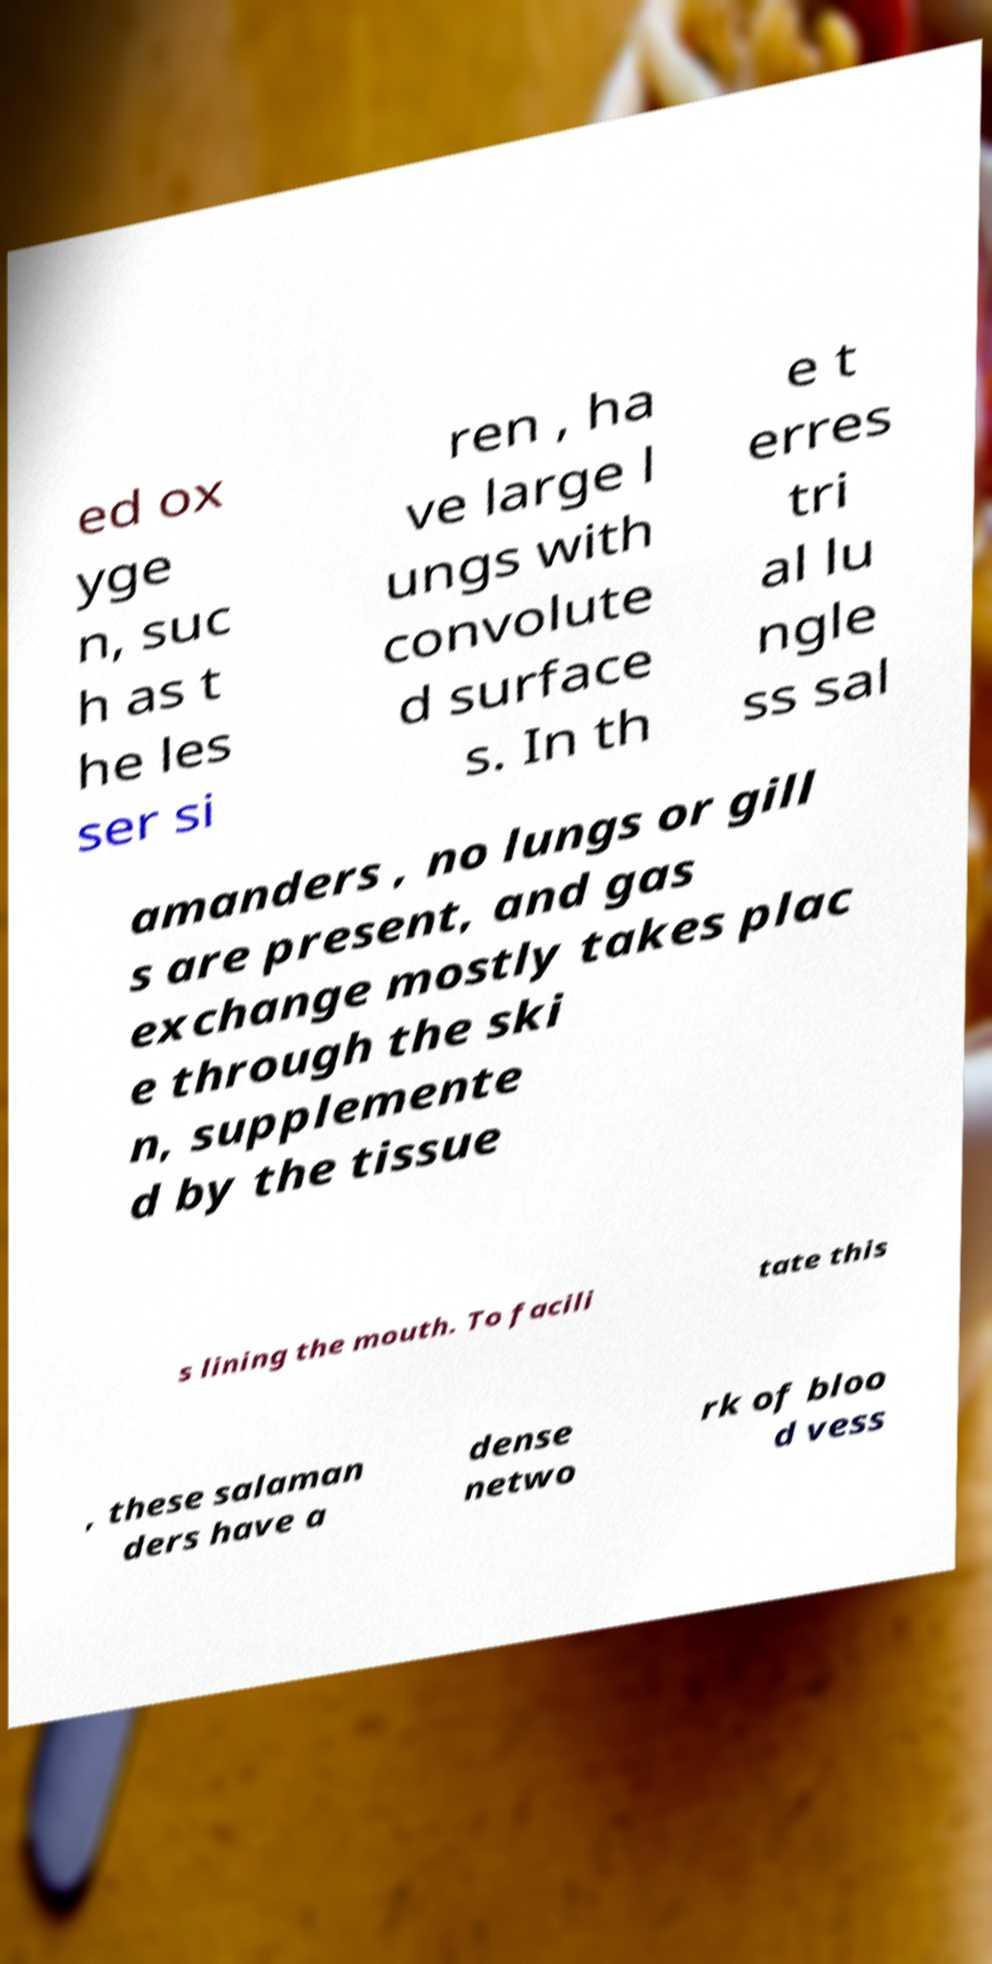Can you read and provide the text displayed in the image?This photo seems to have some interesting text. Can you extract and type it out for me? ed ox yge n, suc h as t he les ser si ren , ha ve large l ungs with convolute d surface s. In th e t erres tri al lu ngle ss sal amanders , no lungs or gill s are present, and gas exchange mostly takes plac e through the ski n, supplemente d by the tissue s lining the mouth. To facili tate this , these salaman ders have a dense netwo rk of bloo d vess 